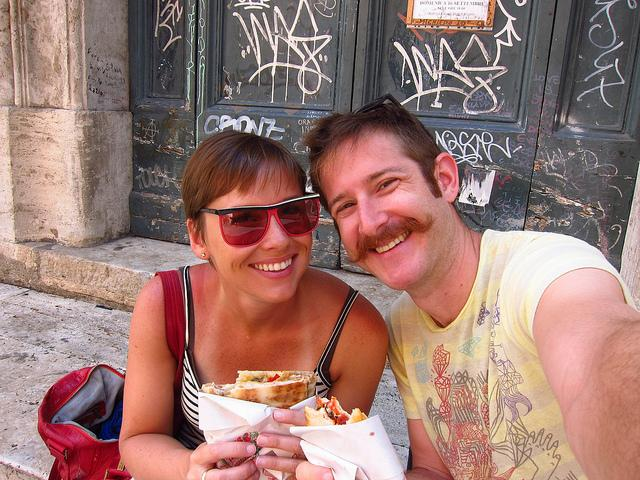Why is she covering her eyes? sunlight 